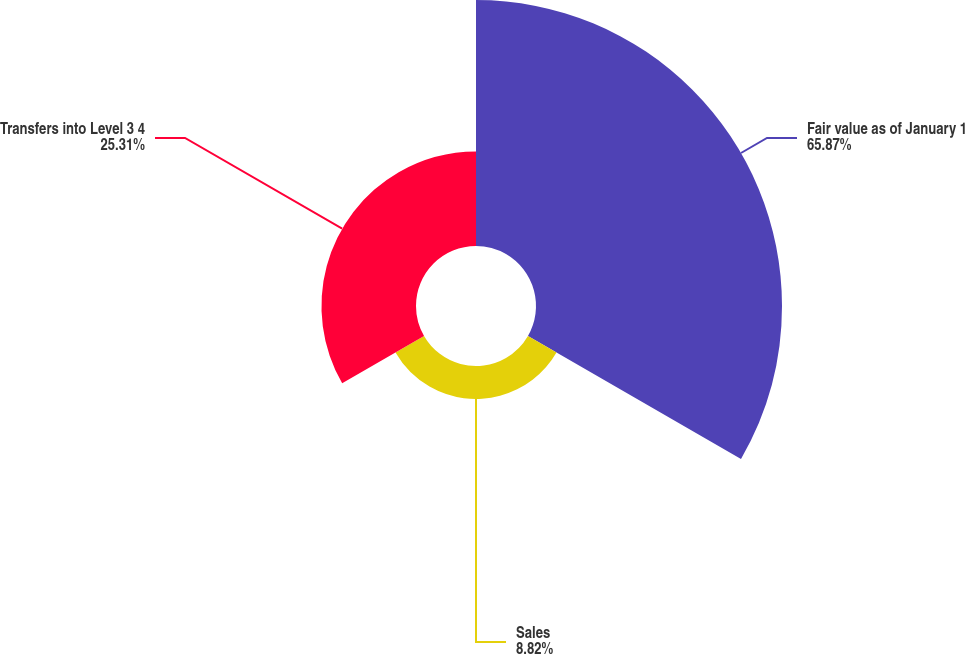Convert chart to OTSL. <chart><loc_0><loc_0><loc_500><loc_500><pie_chart><fcel>Fair value as of January 1<fcel>Sales<fcel>Transfers into Level 3 4<nl><fcel>65.86%<fcel>8.82%<fcel>25.31%<nl></chart> 